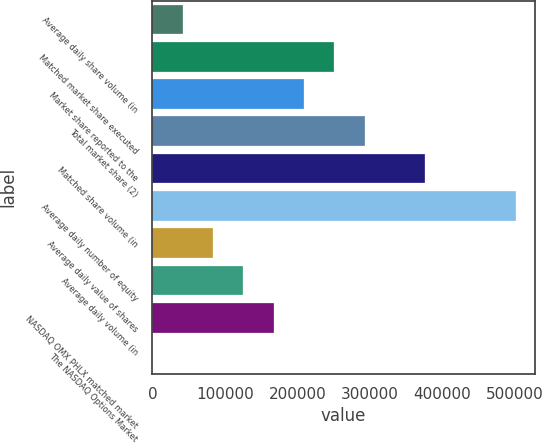<chart> <loc_0><loc_0><loc_500><loc_500><bar_chart><fcel>Average daily share volume (in<fcel>Matched market share executed<fcel>Market share reported to the<fcel>Total market share (2)<fcel>Matched share volume (in<fcel>Average daily number of equity<fcel>Average daily value of shares<fcel>Average daily volume (in<fcel>NASDAQ OMX PHLX matched market<fcel>The NASDAQ Options Market<nl><fcel>41878.2<fcel>251264<fcel>209387<fcel>293141<fcel>376896<fcel>502527<fcel>83755.4<fcel>125633<fcel>167510<fcel>1<nl></chart> 